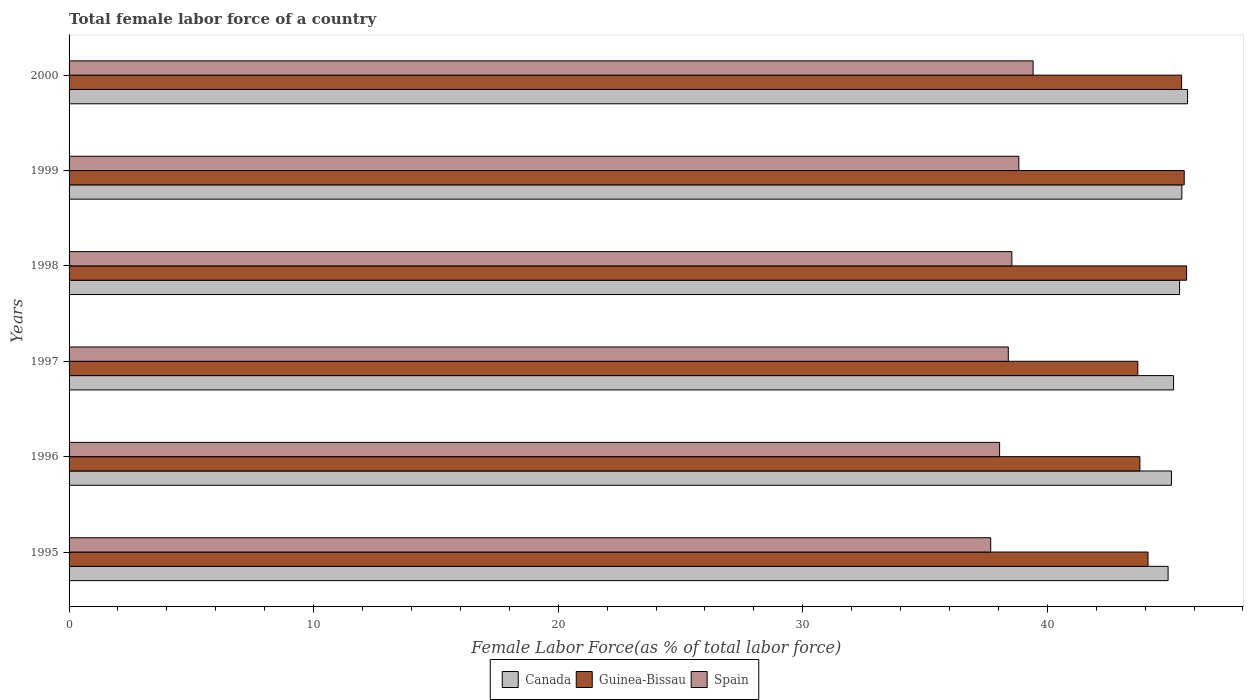Are the number of bars per tick equal to the number of legend labels?
Offer a very short reply. Yes. What is the label of the 6th group of bars from the top?
Make the answer very short. 1995. In how many cases, is the number of bars for a given year not equal to the number of legend labels?
Your answer should be very brief. 0. What is the percentage of female labor force in Canada in 1996?
Offer a terse response. 45.08. Across all years, what is the maximum percentage of female labor force in Guinea-Bissau?
Your answer should be very brief. 45.7. Across all years, what is the minimum percentage of female labor force in Canada?
Provide a succinct answer. 44.94. In which year was the percentage of female labor force in Spain maximum?
Your answer should be compact. 2000. In which year was the percentage of female labor force in Canada minimum?
Offer a very short reply. 1995. What is the total percentage of female labor force in Spain in the graph?
Your answer should be compact. 230.95. What is the difference between the percentage of female labor force in Canada in 1996 and that in 1997?
Provide a short and direct response. -0.09. What is the difference between the percentage of female labor force in Canada in 1996 and the percentage of female labor force in Spain in 2000?
Give a very brief answer. 5.66. What is the average percentage of female labor force in Spain per year?
Give a very brief answer. 38.49. In the year 1997, what is the difference between the percentage of female labor force in Canada and percentage of female labor force in Guinea-Bissau?
Keep it short and to the point. 1.46. What is the ratio of the percentage of female labor force in Guinea-Bissau in 1995 to that in 2000?
Give a very brief answer. 0.97. What is the difference between the highest and the second highest percentage of female labor force in Spain?
Provide a succinct answer. 0.58. What is the difference between the highest and the lowest percentage of female labor force in Guinea-Bissau?
Ensure brevity in your answer.  2. How many bars are there?
Give a very brief answer. 18. Are all the bars in the graph horizontal?
Provide a succinct answer. Yes. Are the values on the major ticks of X-axis written in scientific E-notation?
Keep it short and to the point. No. Does the graph contain any zero values?
Ensure brevity in your answer.  No. Does the graph contain grids?
Offer a terse response. No. How many legend labels are there?
Your answer should be very brief. 3. What is the title of the graph?
Your answer should be very brief. Total female labor force of a country. Does "Equatorial Guinea" appear as one of the legend labels in the graph?
Provide a succinct answer. No. What is the label or title of the X-axis?
Your response must be concise. Female Labor Force(as % of total labor force). What is the label or title of the Y-axis?
Provide a short and direct response. Years. What is the Female Labor Force(as % of total labor force) of Canada in 1995?
Provide a short and direct response. 44.94. What is the Female Labor Force(as % of total labor force) of Guinea-Bissau in 1995?
Give a very brief answer. 44.12. What is the Female Labor Force(as % of total labor force) of Spain in 1995?
Your response must be concise. 37.69. What is the Female Labor Force(as % of total labor force) in Canada in 1996?
Offer a terse response. 45.08. What is the Female Labor Force(as % of total labor force) in Guinea-Bissau in 1996?
Make the answer very short. 43.79. What is the Female Labor Force(as % of total labor force) of Spain in 1996?
Your response must be concise. 38.05. What is the Female Labor Force(as % of total labor force) of Canada in 1997?
Offer a terse response. 45.16. What is the Female Labor Force(as % of total labor force) of Guinea-Bissau in 1997?
Provide a succinct answer. 43.7. What is the Female Labor Force(as % of total labor force) of Spain in 1997?
Your answer should be compact. 38.41. What is the Female Labor Force(as % of total labor force) of Canada in 1998?
Your answer should be compact. 45.41. What is the Female Labor Force(as % of total labor force) in Guinea-Bissau in 1998?
Provide a succinct answer. 45.7. What is the Female Labor Force(as % of total labor force) in Spain in 1998?
Ensure brevity in your answer.  38.55. What is the Female Labor Force(as % of total labor force) in Canada in 1999?
Provide a succinct answer. 45.5. What is the Female Labor Force(as % of total labor force) in Guinea-Bissau in 1999?
Make the answer very short. 45.6. What is the Female Labor Force(as % of total labor force) of Spain in 1999?
Make the answer very short. 38.84. What is the Female Labor Force(as % of total labor force) of Canada in 2000?
Ensure brevity in your answer.  45.74. What is the Female Labor Force(as % of total labor force) of Guinea-Bissau in 2000?
Provide a short and direct response. 45.49. What is the Female Labor Force(as % of total labor force) of Spain in 2000?
Offer a very short reply. 39.42. Across all years, what is the maximum Female Labor Force(as % of total labor force) in Canada?
Your answer should be compact. 45.74. Across all years, what is the maximum Female Labor Force(as % of total labor force) of Guinea-Bissau?
Keep it short and to the point. 45.7. Across all years, what is the maximum Female Labor Force(as % of total labor force) of Spain?
Give a very brief answer. 39.42. Across all years, what is the minimum Female Labor Force(as % of total labor force) of Canada?
Offer a very short reply. 44.94. Across all years, what is the minimum Female Labor Force(as % of total labor force) of Guinea-Bissau?
Provide a short and direct response. 43.7. Across all years, what is the minimum Female Labor Force(as % of total labor force) in Spain?
Provide a short and direct response. 37.69. What is the total Female Labor Force(as % of total labor force) in Canada in the graph?
Offer a very short reply. 271.83. What is the total Female Labor Force(as % of total labor force) in Guinea-Bissau in the graph?
Provide a succinct answer. 268.39. What is the total Female Labor Force(as % of total labor force) of Spain in the graph?
Your answer should be compact. 230.95. What is the difference between the Female Labor Force(as % of total labor force) of Canada in 1995 and that in 1996?
Offer a terse response. -0.14. What is the difference between the Female Labor Force(as % of total labor force) of Guinea-Bissau in 1995 and that in 1996?
Offer a terse response. 0.33. What is the difference between the Female Labor Force(as % of total labor force) of Spain in 1995 and that in 1996?
Make the answer very short. -0.36. What is the difference between the Female Labor Force(as % of total labor force) of Canada in 1995 and that in 1997?
Offer a very short reply. -0.22. What is the difference between the Female Labor Force(as % of total labor force) in Guinea-Bissau in 1995 and that in 1997?
Offer a terse response. 0.42. What is the difference between the Female Labor Force(as % of total labor force) in Spain in 1995 and that in 1997?
Keep it short and to the point. -0.72. What is the difference between the Female Labor Force(as % of total labor force) in Canada in 1995 and that in 1998?
Your response must be concise. -0.47. What is the difference between the Female Labor Force(as % of total labor force) of Guinea-Bissau in 1995 and that in 1998?
Keep it short and to the point. -1.58. What is the difference between the Female Labor Force(as % of total labor force) of Spain in 1995 and that in 1998?
Provide a short and direct response. -0.86. What is the difference between the Female Labor Force(as % of total labor force) in Canada in 1995 and that in 1999?
Offer a terse response. -0.56. What is the difference between the Female Labor Force(as % of total labor force) in Guinea-Bissau in 1995 and that in 1999?
Your answer should be compact. -1.48. What is the difference between the Female Labor Force(as % of total labor force) of Spain in 1995 and that in 1999?
Make the answer very short. -1.15. What is the difference between the Female Labor Force(as % of total labor force) in Canada in 1995 and that in 2000?
Provide a succinct answer. -0.8. What is the difference between the Female Labor Force(as % of total labor force) of Guinea-Bissau in 1995 and that in 2000?
Keep it short and to the point. -1.37. What is the difference between the Female Labor Force(as % of total labor force) in Spain in 1995 and that in 2000?
Provide a succinct answer. -1.73. What is the difference between the Female Labor Force(as % of total labor force) in Canada in 1996 and that in 1997?
Provide a short and direct response. -0.09. What is the difference between the Female Labor Force(as % of total labor force) of Guinea-Bissau in 1996 and that in 1997?
Your response must be concise. 0.09. What is the difference between the Female Labor Force(as % of total labor force) of Spain in 1996 and that in 1997?
Ensure brevity in your answer.  -0.35. What is the difference between the Female Labor Force(as % of total labor force) in Canada in 1996 and that in 1998?
Provide a succinct answer. -0.33. What is the difference between the Female Labor Force(as % of total labor force) in Guinea-Bissau in 1996 and that in 1998?
Your response must be concise. -1.91. What is the difference between the Female Labor Force(as % of total labor force) of Spain in 1996 and that in 1998?
Offer a terse response. -0.5. What is the difference between the Female Labor Force(as % of total labor force) in Canada in 1996 and that in 1999?
Make the answer very short. -0.43. What is the difference between the Female Labor Force(as % of total labor force) of Guinea-Bissau in 1996 and that in 1999?
Make the answer very short. -1.81. What is the difference between the Female Labor Force(as % of total labor force) in Spain in 1996 and that in 1999?
Ensure brevity in your answer.  -0.79. What is the difference between the Female Labor Force(as % of total labor force) in Canada in 1996 and that in 2000?
Ensure brevity in your answer.  -0.66. What is the difference between the Female Labor Force(as % of total labor force) of Guinea-Bissau in 1996 and that in 2000?
Offer a very short reply. -1.71. What is the difference between the Female Labor Force(as % of total labor force) of Spain in 1996 and that in 2000?
Your answer should be very brief. -1.37. What is the difference between the Female Labor Force(as % of total labor force) in Canada in 1997 and that in 1998?
Give a very brief answer. -0.25. What is the difference between the Female Labor Force(as % of total labor force) in Guinea-Bissau in 1997 and that in 1998?
Your response must be concise. -2. What is the difference between the Female Labor Force(as % of total labor force) in Spain in 1997 and that in 1998?
Give a very brief answer. -0.15. What is the difference between the Female Labor Force(as % of total labor force) of Canada in 1997 and that in 1999?
Provide a succinct answer. -0.34. What is the difference between the Female Labor Force(as % of total labor force) in Guinea-Bissau in 1997 and that in 1999?
Offer a terse response. -1.9. What is the difference between the Female Labor Force(as % of total labor force) of Spain in 1997 and that in 1999?
Offer a very short reply. -0.43. What is the difference between the Female Labor Force(as % of total labor force) of Canada in 1997 and that in 2000?
Make the answer very short. -0.57. What is the difference between the Female Labor Force(as % of total labor force) of Guinea-Bissau in 1997 and that in 2000?
Your answer should be very brief. -1.79. What is the difference between the Female Labor Force(as % of total labor force) of Spain in 1997 and that in 2000?
Make the answer very short. -1.01. What is the difference between the Female Labor Force(as % of total labor force) in Canada in 1998 and that in 1999?
Make the answer very short. -0.09. What is the difference between the Female Labor Force(as % of total labor force) of Guinea-Bissau in 1998 and that in 1999?
Offer a terse response. 0.1. What is the difference between the Female Labor Force(as % of total labor force) in Spain in 1998 and that in 1999?
Give a very brief answer. -0.29. What is the difference between the Female Labor Force(as % of total labor force) in Canada in 1998 and that in 2000?
Offer a terse response. -0.33. What is the difference between the Female Labor Force(as % of total labor force) of Guinea-Bissau in 1998 and that in 2000?
Your answer should be very brief. 0.2. What is the difference between the Female Labor Force(as % of total labor force) of Spain in 1998 and that in 2000?
Offer a terse response. -0.87. What is the difference between the Female Labor Force(as % of total labor force) of Canada in 1999 and that in 2000?
Keep it short and to the point. -0.23. What is the difference between the Female Labor Force(as % of total labor force) of Guinea-Bissau in 1999 and that in 2000?
Provide a short and direct response. 0.11. What is the difference between the Female Labor Force(as % of total labor force) in Spain in 1999 and that in 2000?
Give a very brief answer. -0.58. What is the difference between the Female Labor Force(as % of total labor force) in Canada in 1995 and the Female Labor Force(as % of total labor force) in Guinea-Bissau in 1996?
Make the answer very short. 1.15. What is the difference between the Female Labor Force(as % of total labor force) in Canada in 1995 and the Female Labor Force(as % of total labor force) in Spain in 1996?
Ensure brevity in your answer.  6.89. What is the difference between the Female Labor Force(as % of total labor force) of Guinea-Bissau in 1995 and the Female Labor Force(as % of total labor force) of Spain in 1996?
Provide a short and direct response. 6.07. What is the difference between the Female Labor Force(as % of total labor force) in Canada in 1995 and the Female Labor Force(as % of total labor force) in Guinea-Bissau in 1997?
Offer a very short reply. 1.24. What is the difference between the Female Labor Force(as % of total labor force) of Canada in 1995 and the Female Labor Force(as % of total labor force) of Spain in 1997?
Offer a very short reply. 6.53. What is the difference between the Female Labor Force(as % of total labor force) of Guinea-Bissau in 1995 and the Female Labor Force(as % of total labor force) of Spain in 1997?
Give a very brief answer. 5.71. What is the difference between the Female Labor Force(as % of total labor force) of Canada in 1995 and the Female Labor Force(as % of total labor force) of Guinea-Bissau in 1998?
Offer a terse response. -0.76. What is the difference between the Female Labor Force(as % of total labor force) of Canada in 1995 and the Female Labor Force(as % of total labor force) of Spain in 1998?
Ensure brevity in your answer.  6.39. What is the difference between the Female Labor Force(as % of total labor force) in Guinea-Bissau in 1995 and the Female Labor Force(as % of total labor force) in Spain in 1998?
Ensure brevity in your answer.  5.57. What is the difference between the Female Labor Force(as % of total labor force) of Canada in 1995 and the Female Labor Force(as % of total labor force) of Guinea-Bissau in 1999?
Provide a short and direct response. -0.66. What is the difference between the Female Labor Force(as % of total labor force) of Canada in 1995 and the Female Labor Force(as % of total labor force) of Spain in 1999?
Keep it short and to the point. 6.1. What is the difference between the Female Labor Force(as % of total labor force) of Guinea-Bissau in 1995 and the Female Labor Force(as % of total labor force) of Spain in 1999?
Your answer should be very brief. 5.28. What is the difference between the Female Labor Force(as % of total labor force) in Canada in 1995 and the Female Labor Force(as % of total labor force) in Guinea-Bissau in 2000?
Ensure brevity in your answer.  -0.55. What is the difference between the Female Labor Force(as % of total labor force) in Canada in 1995 and the Female Labor Force(as % of total labor force) in Spain in 2000?
Offer a terse response. 5.52. What is the difference between the Female Labor Force(as % of total labor force) of Guinea-Bissau in 1995 and the Female Labor Force(as % of total labor force) of Spain in 2000?
Your answer should be compact. 4.7. What is the difference between the Female Labor Force(as % of total labor force) in Canada in 1996 and the Female Labor Force(as % of total labor force) in Guinea-Bissau in 1997?
Ensure brevity in your answer.  1.38. What is the difference between the Female Labor Force(as % of total labor force) in Canada in 1996 and the Female Labor Force(as % of total labor force) in Spain in 1997?
Your response must be concise. 6.67. What is the difference between the Female Labor Force(as % of total labor force) in Guinea-Bissau in 1996 and the Female Labor Force(as % of total labor force) in Spain in 1997?
Make the answer very short. 5.38. What is the difference between the Female Labor Force(as % of total labor force) in Canada in 1996 and the Female Labor Force(as % of total labor force) in Guinea-Bissau in 1998?
Give a very brief answer. -0.62. What is the difference between the Female Labor Force(as % of total labor force) of Canada in 1996 and the Female Labor Force(as % of total labor force) of Spain in 1998?
Offer a terse response. 6.53. What is the difference between the Female Labor Force(as % of total labor force) in Guinea-Bissau in 1996 and the Female Labor Force(as % of total labor force) in Spain in 1998?
Keep it short and to the point. 5.24. What is the difference between the Female Labor Force(as % of total labor force) of Canada in 1996 and the Female Labor Force(as % of total labor force) of Guinea-Bissau in 1999?
Provide a short and direct response. -0.52. What is the difference between the Female Labor Force(as % of total labor force) of Canada in 1996 and the Female Labor Force(as % of total labor force) of Spain in 1999?
Your answer should be compact. 6.24. What is the difference between the Female Labor Force(as % of total labor force) of Guinea-Bissau in 1996 and the Female Labor Force(as % of total labor force) of Spain in 1999?
Make the answer very short. 4.95. What is the difference between the Female Labor Force(as % of total labor force) in Canada in 1996 and the Female Labor Force(as % of total labor force) in Guinea-Bissau in 2000?
Make the answer very short. -0.42. What is the difference between the Female Labor Force(as % of total labor force) in Canada in 1996 and the Female Labor Force(as % of total labor force) in Spain in 2000?
Your answer should be compact. 5.66. What is the difference between the Female Labor Force(as % of total labor force) in Guinea-Bissau in 1996 and the Female Labor Force(as % of total labor force) in Spain in 2000?
Your answer should be compact. 4.37. What is the difference between the Female Labor Force(as % of total labor force) in Canada in 1997 and the Female Labor Force(as % of total labor force) in Guinea-Bissau in 1998?
Your answer should be compact. -0.53. What is the difference between the Female Labor Force(as % of total labor force) in Canada in 1997 and the Female Labor Force(as % of total labor force) in Spain in 1998?
Give a very brief answer. 6.61. What is the difference between the Female Labor Force(as % of total labor force) in Guinea-Bissau in 1997 and the Female Labor Force(as % of total labor force) in Spain in 1998?
Provide a succinct answer. 5.15. What is the difference between the Female Labor Force(as % of total labor force) of Canada in 1997 and the Female Labor Force(as % of total labor force) of Guinea-Bissau in 1999?
Keep it short and to the point. -0.44. What is the difference between the Female Labor Force(as % of total labor force) in Canada in 1997 and the Female Labor Force(as % of total labor force) in Spain in 1999?
Your response must be concise. 6.33. What is the difference between the Female Labor Force(as % of total labor force) in Guinea-Bissau in 1997 and the Female Labor Force(as % of total labor force) in Spain in 1999?
Provide a succinct answer. 4.86. What is the difference between the Female Labor Force(as % of total labor force) of Canada in 1997 and the Female Labor Force(as % of total labor force) of Guinea-Bissau in 2000?
Offer a very short reply. -0.33. What is the difference between the Female Labor Force(as % of total labor force) of Canada in 1997 and the Female Labor Force(as % of total labor force) of Spain in 2000?
Your response must be concise. 5.74. What is the difference between the Female Labor Force(as % of total labor force) of Guinea-Bissau in 1997 and the Female Labor Force(as % of total labor force) of Spain in 2000?
Your answer should be compact. 4.28. What is the difference between the Female Labor Force(as % of total labor force) of Canada in 1998 and the Female Labor Force(as % of total labor force) of Guinea-Bissau in 1999?
Ensure brevity in your answer.  -0.19. What is the difference between the Female Labor Force(as % of total labor force) in Canada in 1998 and the Female Labor Force(as % of total labor force) in Spain in 1999?
Your response must be concise. 6.57. What is the difference between the Female Labor Force(as % of total labor force) in Guinea-Bissau in 1998 and the Female Labor Force(as % of total labor force) in Spain in 1999?
Provide a short and direct response. 6.86. What is the difference between the Female Labor Force(as % of total labor force) of Canada in 1998 and the Female Labor Force(as % of total labor force) of Guinea-Bissau in 2000?
Your answer should be compact. -0.08. What is the difference between the Female Labor Force(as % of total labor force) in Canada in 1998 and the Female Labor Force(as % of total labor force) in Spain in 2000?
Offer a very short reply. 5.99. What is the difference between the Female Labor Force(as % of total labor force) of Guinea-Bissau in 1998 and the Female Labor Force(as % of total labor force) of Spain in 2000?
Provide a short and direct response. 6.28. What is the difference between the Female Labor Force(as % of total labor force) of Canada in 1999 and the Female Labor Force(as % of total labor force) of Guinea-Bissau in 2000?
Make the answer very short. 0.01. What is the difference between the Female Labor Force(as % of total labor force) of Canada in 1999 and the Female Labor Force(as % of total labor force) of Spain in 2000?
Your answer should be compact. 6.08. What is the difference between the Female Labor Force(as % of total labor force) in Guinea-Bissau in 1999 and the Female Labor Force(as % of total labor force) in Spain in 2000?
Give a very brief answer. 6.18. What is the average Female Labor Force(as % of total labor force) of Canada per year?
Your answer should be very brief. 45.3. What is the average Female Labor Force(as % of total labor force) in Guinea-Bissau per year?
Your response must be concise. 44.73. What is the average Female Labor Force(as % of total labor force) in Spain per year?
Make the answer very short. 38.49. In the year 1995, what is the difference between the Female Labor Force(as % of total labor force) in Canada and Female Labor Force(as % of total labor force) in Guinea-Bissau?
Make the answer very short. 0.82. In the year 1995, what is the difference between the Female Labor Force(as % of total labor force) in Canada and Female Labor Force(as % of total labor force) in Spain?
Offer a terse response. 7.25. In the year 1995, what is the difference between the Female Labor Force(as % of total labor force) of Guinea-Bissau and Female Labor Force(as % of total labor force) of Spain?
Keep it short and to the point. 6.43. In the year 1996, what is the difference between the Female Labor Force(as % of total labor force) in Canada and Female Labor Force(as % of total labor force) in Guinea-Bissau?
Your answer should be compact. 1.29. In the year 1996, what is the difference between the Female Labor Force(as % of total labor force) in Canada and Female Labor Force(as % of total labor force) in Spain?
Your response must be concise. 7.03. In the year 1996, what is the difference between the Female Labor Force(as % of total labor force) of Guinea-Bissau and Female Labor Force(as % of total labor force) of Spain?
Give a very brief answer. 5.74. In the year 1997, what is the difference between the Female Labor Force(as % of total labor force) in Canada and Female Labor Force(as % of total labor force) in Guinea-Bissau?
Provide a short and direct response. 1.46. In the year 1997, what is the difference between the Female Labor Force(as % of total labor force) in Canada and Female Labor Force(as % of total labor force) in Spain?
Ensure brevity in your answer.  6.76. In the year 1997, what is the difference between the Female Labor Force(as % of total labor force) in Guinea-Bissau and Female Labor Force(as % of total labor force) in Spain?
Keep it short and to the point. 5.3. In the year 1998, what is the difference between the Female Labor Force(as % of total labor force) in Canada and Female Labor Force(as % of total labor force) in Guinea-Bissau?
Give a very brief answer. -0.29. In the year 1998, what is the difference between the Female Labor Force(as % of total labor force) of Canada and Female Labor Force(as % of total labor force) of Spain?
Your response must be concise. 6.86. In the year 1998, what is the difference between the Female Labor Force(as % of total labor force) in Guinea-Bissau and Female Labor Force(as % of total labor force) in Spain?
Offer a terse response. 7.15. In the year 1999, what is the difference between the Female Labor Force(as % of total labor force) in Canada and Female Labor Force(as % of total labor force) in Guinea-Bissau?
Give a very brief answer. -0.1. In the year 1999, what is the difference between the Female Labor Force(as % of total labor force) in Canada and Female Labor Force(as % of total labor force) in Spain?
Give a very brief answer. 6.67. In the year 1999, what is the difference between the Female Labor Force(as % of total labor force) of Guinea-Bissau and Female Labor Force(as % of total labor force) of Spain?
Make the answer very short. 6.76. In the year 2000, what is the difference between the Female Labor Force(as % of total labor force) of Canada and Female Labor Force(as % of total labor force) of Guinea-Bissau?
Provide a short and direct response. 0.24. In the year 2000, what is the difference between the Female Labor Force(as % of total labor force) of Canada and Female Labor Force(as % of total labor force) of Spain?
Your answer should be very brief. 6.32. In the year 2000, what is the difference between the Female Labor Force(as % of total labor force) of Guinea-Bissau and Female Labor Force(as % of total labor force) of Spain?
Your response must be concise. 6.07. What is the ratio of the Female Labor Force(as % of total labor force) in Guinea-Bissau in 1995 to that in 1996?
Offer a terse response. 1.01. What is the ratio of the Female Labor Force(as % of total labor force) of Guinea-Bissau in 1995 to that in 1997?
Keep it short and to the point. 1.01. What is the ratio of the Female Labor Force(as % of total labor force) of Spain in 1995 to that in 1997?
Ensure brevity in your answer.  0.98. What is the ratio of the Female Labor Force(as % of total labor force) of Guinea-Bissau in 1995 to that in 1998?
Your answer should be very brief. 0.97. What is the ratio of the Female Labor Force(as % of total labor force) of Spain in 1995 to that in 1998?
Ensure brevity in your answer.  0.98. What is the ratio of the Female Labor Force(as % of total labor force) of Canada in 1995 to that in 1999?
Ensure brevity in your answer.  0.99. What is the ratio of the Female Labor Force(as % of total labor force) in Guinea-Bissau in 1995 to that in 1999?
Make the answer very short. 0.97. What is the ratio of the Female Labor Force(as % of total labor force) in Spain in 1995 to that in 1999?
Your response must be concise. 0.97. What is the ratio of the Female Labor Force(as % of total labor force) of Canada in 1995 to that in 2000?
Your answer should be compact. 0.98. What is the ratio of the Female Labor Force(as % of total labor force) of Guinea-Bissau in 1995 to that in 2000?
Give a very brief answer. 0.97. What is the ratio of the Female Labor Force(as % of total labor force) of Spain in 1995 to that in 2000?
Provide a succinct answer. 0.96. What is the ratio of the Female Labor Force(as % of total labor force) of Guinea-Bissau in 1996 to that in 1997?
Your answer should be very brief. 1. What is the ratio of the Female Labor Force(as % of total labor force) in Spain in 1996 to that in 1997?
Give a very brief answer. 0.99. What is the ratio of the Female Labor Force(as % of total labor force) of Canada in 1996 to that in 1998?
Ensure brevity in your answer.  0.99. What is the ratio of the Female Labor Force(as % of total labor force) in Guinea-Bissau in 1996 to that in 1998?
Make the answer very short. 0.96. What is the ratio of the Female Labor Force(as % of total labor force) of Spain in 1996 to that in 1998?
Your answer should be compact. 0.99. What is the ratio of the Female Labor Force(as % of total labor force) in Canada in 1996 to that in 1999?
Ensure brevity in your answer.  0.99. What is the ratio of the Female Labor Force(as % of total labor force) of Guinea-Bissau in 1996 to that in 1999?
Your response must be concise. 0.96. What is the ratio of the Female Labor Force(as % of total labor force) in Spain in 1996 to that in 1999?
Make the answer very short. 0.98. What is the ratio of the Female Labor Force(as % of total labor force) of Canada in 1996 to that in 2000?
Keep it short and to the point. 0.99. What is the ratio of the Female Labor Force(as % of total labor force) of Guinea-Bissau in 1996 to that in 2000?
Provide a short and direct response. 0.96. What is the ratio of the Female Labor Force(as % of total labor force) of Spain in 1996 to that in 2000?
Your response must be concise. 0.97. What is the ratio of the Female Labor Force(as % of total labor force) in Canada in 1997 to that in 1998?
Make the answer very short. 0.99. What is the ratio of the Female Labor Force(as % of total labor force) of Guinea-Bissau in 1997 to that in 1998?
Ensure brevity in your answer.  0.96. What is the ratio of the Female Labor Force(as % of total labor force) in Guinea-Bissau in 1997 to that in 1999?
Provide a succinct answer. 0.96. What is the ratio of the Female Labor Force(as % of total labor force) in Spain in 1997 to that in 1999?
Offer a very short reply. 0.99. What is the ratio of the Female Labor Force(as % of total labor force) of Canada in 1997 to that in 2000?
Provide a short and direct response. 0.99. What is the ratio of the Female Labor Force(as % of total labor force) in Guinea-Bissau in 1997 to that in 2000?
Offer a terse response. 0.96. What is the ratio of the Female Labor Force(as % of total labor force) of Spain in 1997 to that in 2000?
Provide a succinct answer. 0.97. What is the ratio of the Female Labor Force(as % of total labor force) of Guinea-Bissau in 1998 to that in 1999?
Your answer should be compact. 1. What is the ratio of the Female Labor Force(as % of total labor force) in Spain in 1998 to that in 1999?
Your response must be concise. 0.99. What is the ratio of the Female Labor Force(as % of total labor force) in Guinea-Bissau in 1998 to that in 2000?
Provide a short and direct response. 1. What is the ratio of the Female Labor Force(as % of total labor force) of Canada in 1999 to that in 2000?
Provide a succinct answer. 0.99. What is the ratio of the Female Labor Force(as % of total labor force) in Guinea-Bissau in 1999 to that in 2000?
Make the answer very short. 1. What is the ratio of the Female Labor Force(as % of total labor force) in Spain in 1999 to that in 2000?
Offer a very short reply. 0.99. What is the difference between the highest and the second highest Female Labor Force(as % of total labor force) of Canada?
Your answer should be compact. 0.23. What is the difference between the highest and the second highest Female Labor Force(as % of total labor force) in Guinea-Bissau?
Your answer should be compact. 0.1. What is the difference between the highest and the second highest Female Labor Force(as % of total labor force) of Spain?
Keep it short and to the point. 0.58. What is the difference between the highest and the lowest Female Labor Force(as % of total labor force) in Canada?
Provide a short and direct response. 0.8. What is the difference between the highest and the lowest Female Labor Force(as % of total labor force) of Guinea-Bissau?
Make the answer very short. 2. What is the difference between the highest and the lowest Female Labor Force(as % of total labor force) in Spain?
Offer a very short reply. 1.73. 